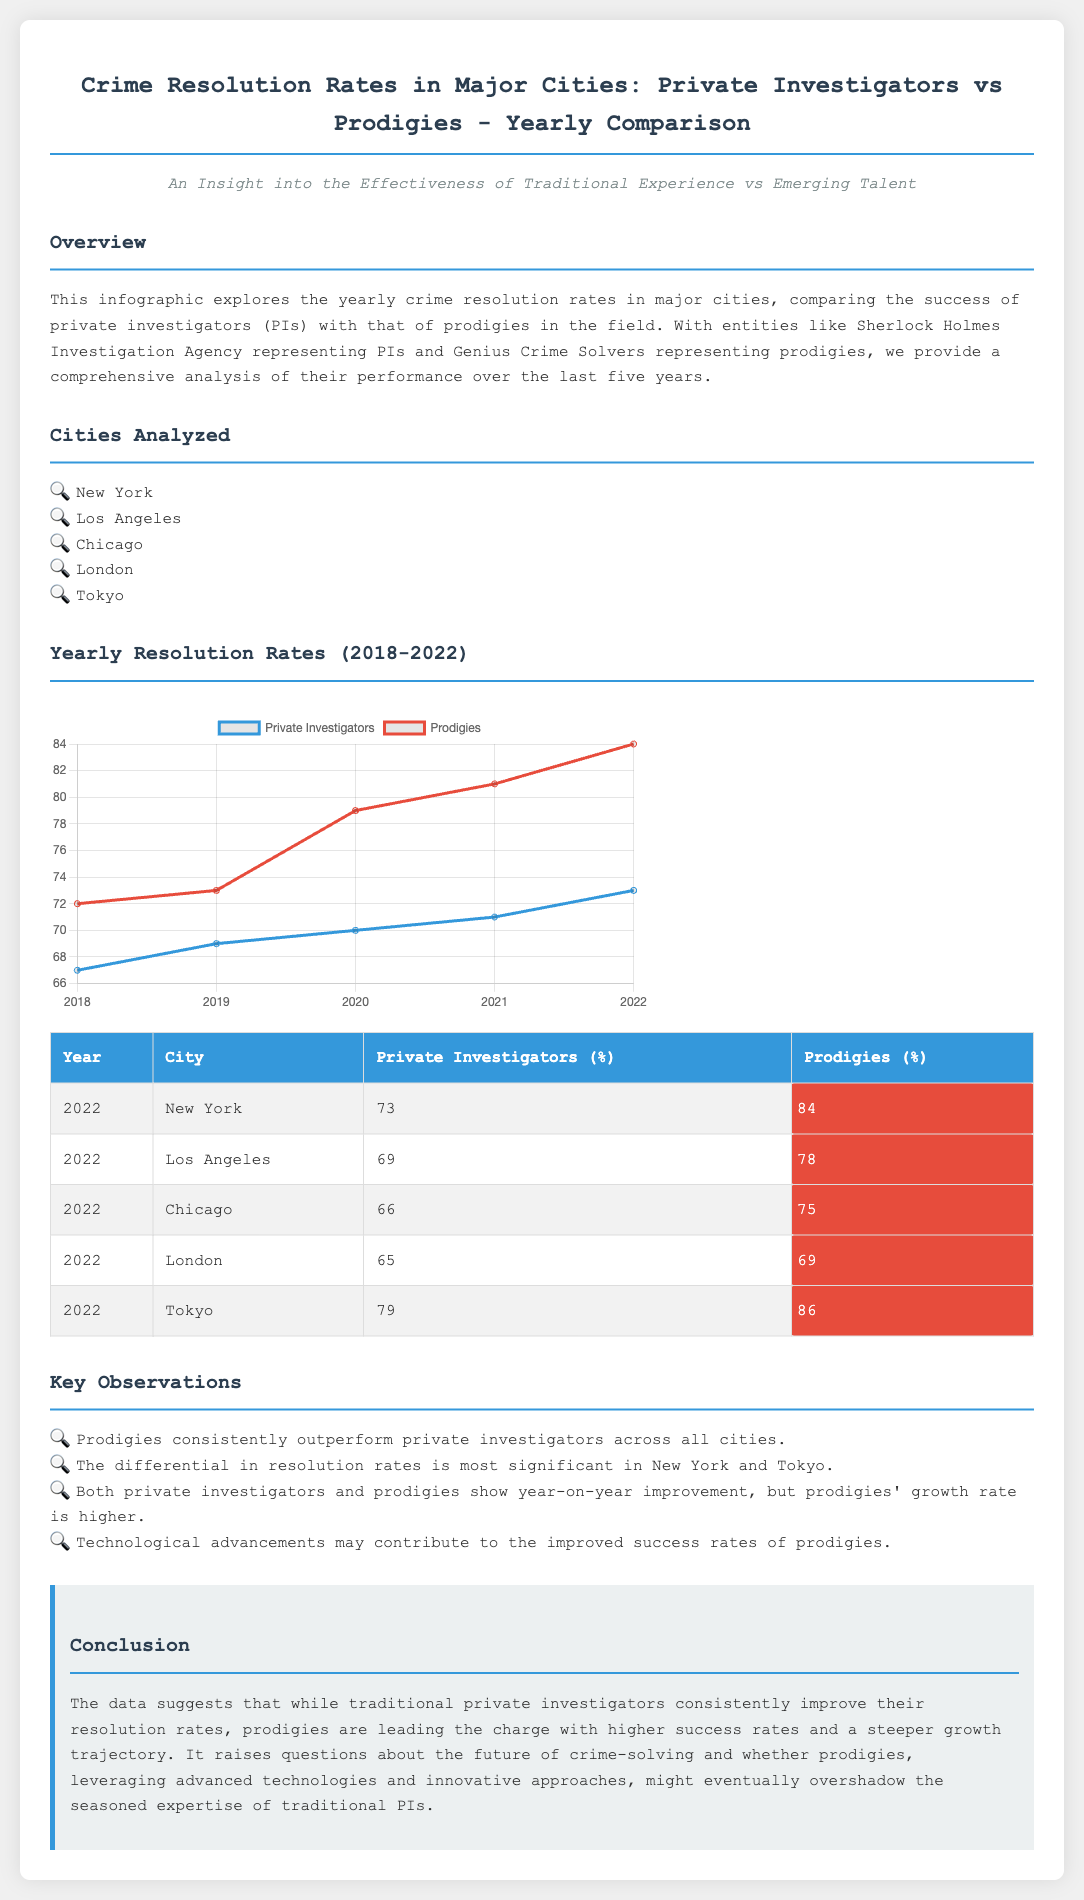what year had the highest resolution rate for private investigators in New York? The highest resolution rate for private investigators in New York was in 2022, with a rate of 73%.
Answer: 2022 which city had the lowest resolution rate for prodigies in 2022? In 2022, London had the lowest resolution rate for prodigies at 69%.
Answer: London what percentage of crime resolution did private investigators achieve in Chicago in 2022? In 2022, private investigators achieved a resolution rate of 66% in Chicago.
Answer: 66% which investigator type generally outperforms the other? The data suggests that prodigies generally outperform private investigators across all cities analyzed.
Answer: Prodigies what is the trend in the resolution rates for both private investigators and prodigies from 2018 to 2022? Both private investigators and prodigies show an increase in resolution rates from 2018 to 2022, with prodigies having a higher growth trajectory.
Answer: Increase how many cities were analyzed in the infographic? The infographic analyzed a total of 5 major cities.
Answer: 5 in which year did private investigators reach a resolution rate of 71%? Private investigators reached a resolution rate of 71% in the year 2021.
Answer: 2021 what color represents prodigies in the chart? In the chart, prodigies are represented by the color red (e74c3c).
Answer: Red 